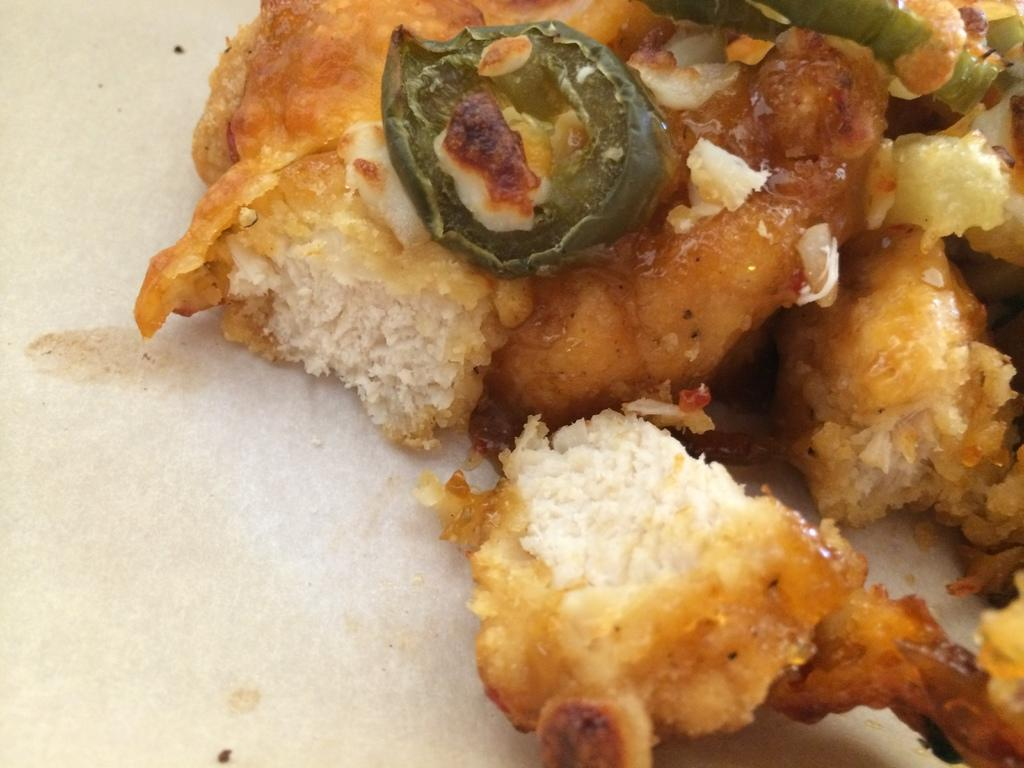What type of food can be seen in the image? The image contains food, but the specific type cannot be determined from the provided facts. What colors are present in the food? The food has white, brown, and green colors. What is the color of the surface on which the food is placed? The food is on a white surface. What type of bucket is used to catch the current in the image? There is no bucket or current present in the image. 